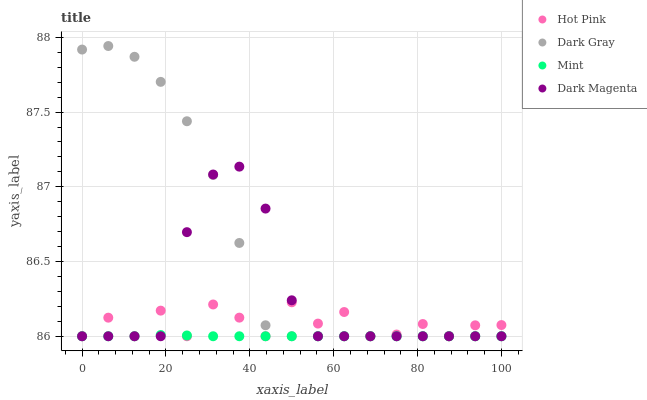Does Mint have the minimum area under the curve?
Answer yes or no. Yes. Does Dark Gray have the maximum area under the curve?
Answer yes or no. Yes. Does Hot Pink have the minimum area under the curve?
Answer yes or no. No. Does Hot Pink have the maximum area under the curve?
Answer yes or no. No. Is Mint the smoothest?
Answer yes or no. Yes. Is Hot Pink the roughest?
Answer yes or no. Yes. Is Hot Pink the smoothest?
Answer yes or no. No. Is Mint the roughest?
Answer yes or no. No. Does Dark Gray have the lowest value?
Answer yes or no. Yes. Does Dark Gray have the highest value?
Answer yes or no. Yes. Does Hot Pink have the highest value?
Answer yes or no. No. Does Mint intersect Hot Pink?
Answer yes or no. Yes. Is Mint less than Hot Pink?
Answer yes or no. No. Is Mint greater than Hot Pink?
Answer yes or no. No. 